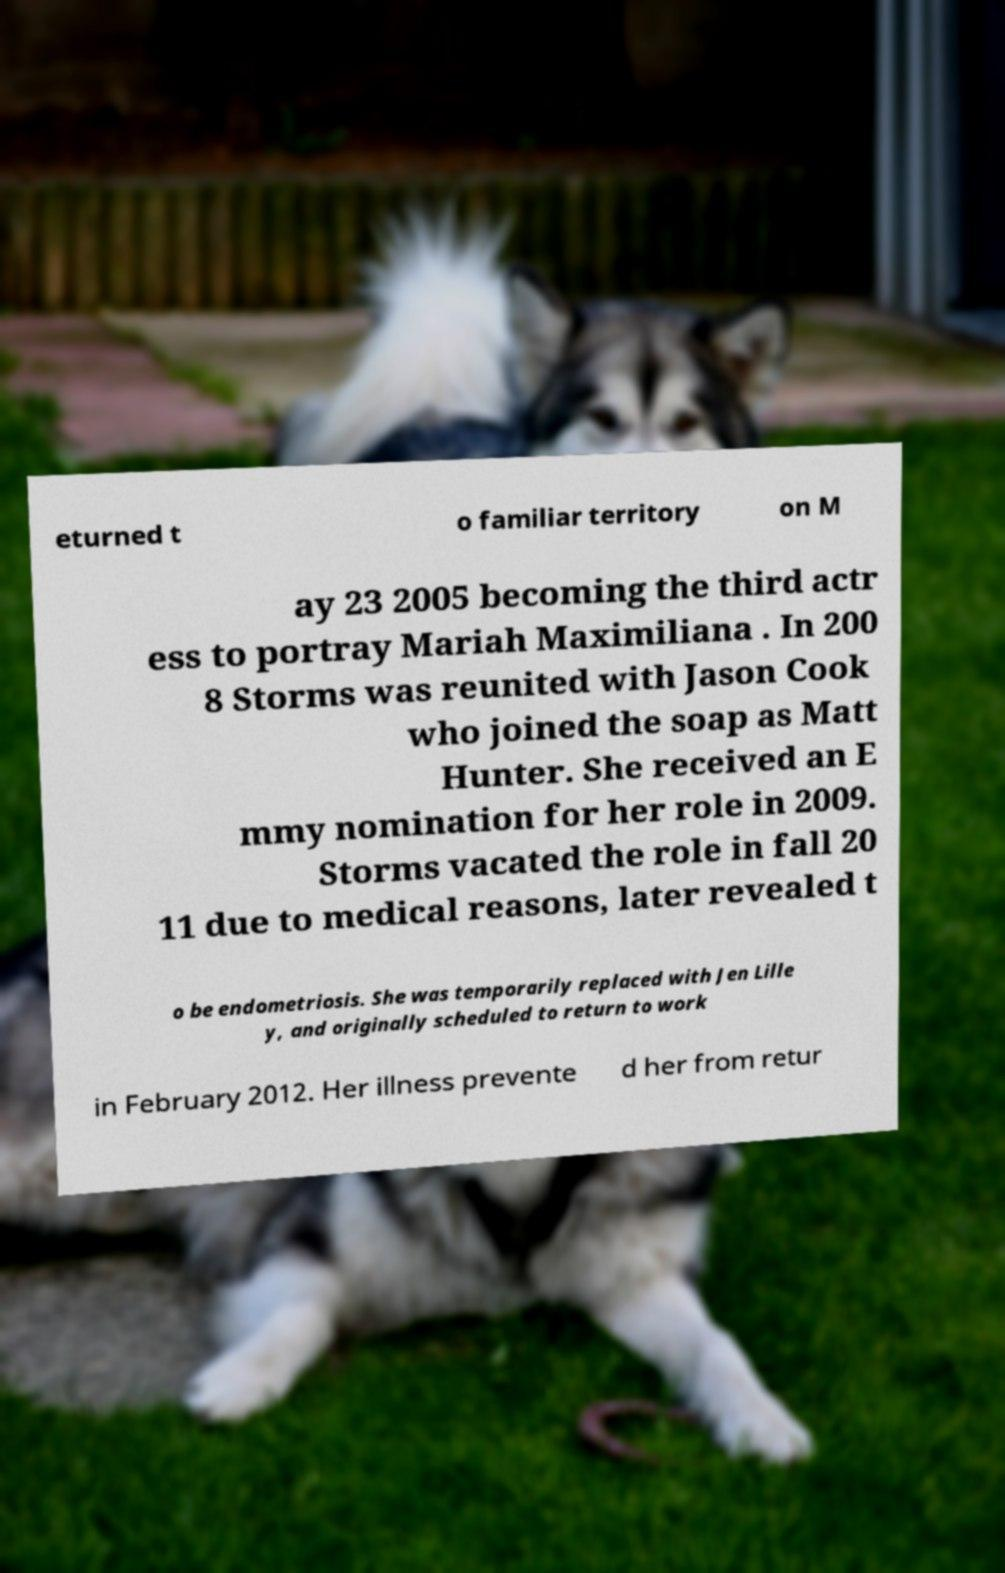I need the written content from this picture converted into text. Can you do that? eturned t o familiar territory on M ay 23 2005 becoming the third actr ess to portray Mariah Maximiliana . In 200 8 Storms was reunited with Jason Cook who joined the soap as Matt Hunter. She received an E mmy nomination for her role in 2009. Storms vacated the role in fall 20 11 due to medical reasons, later revealed t o be endometriosis. She was temporarily replaced with Jen Lille y, and originally scheduled to return to work in February 2012. Her illness prevente d her from retur 